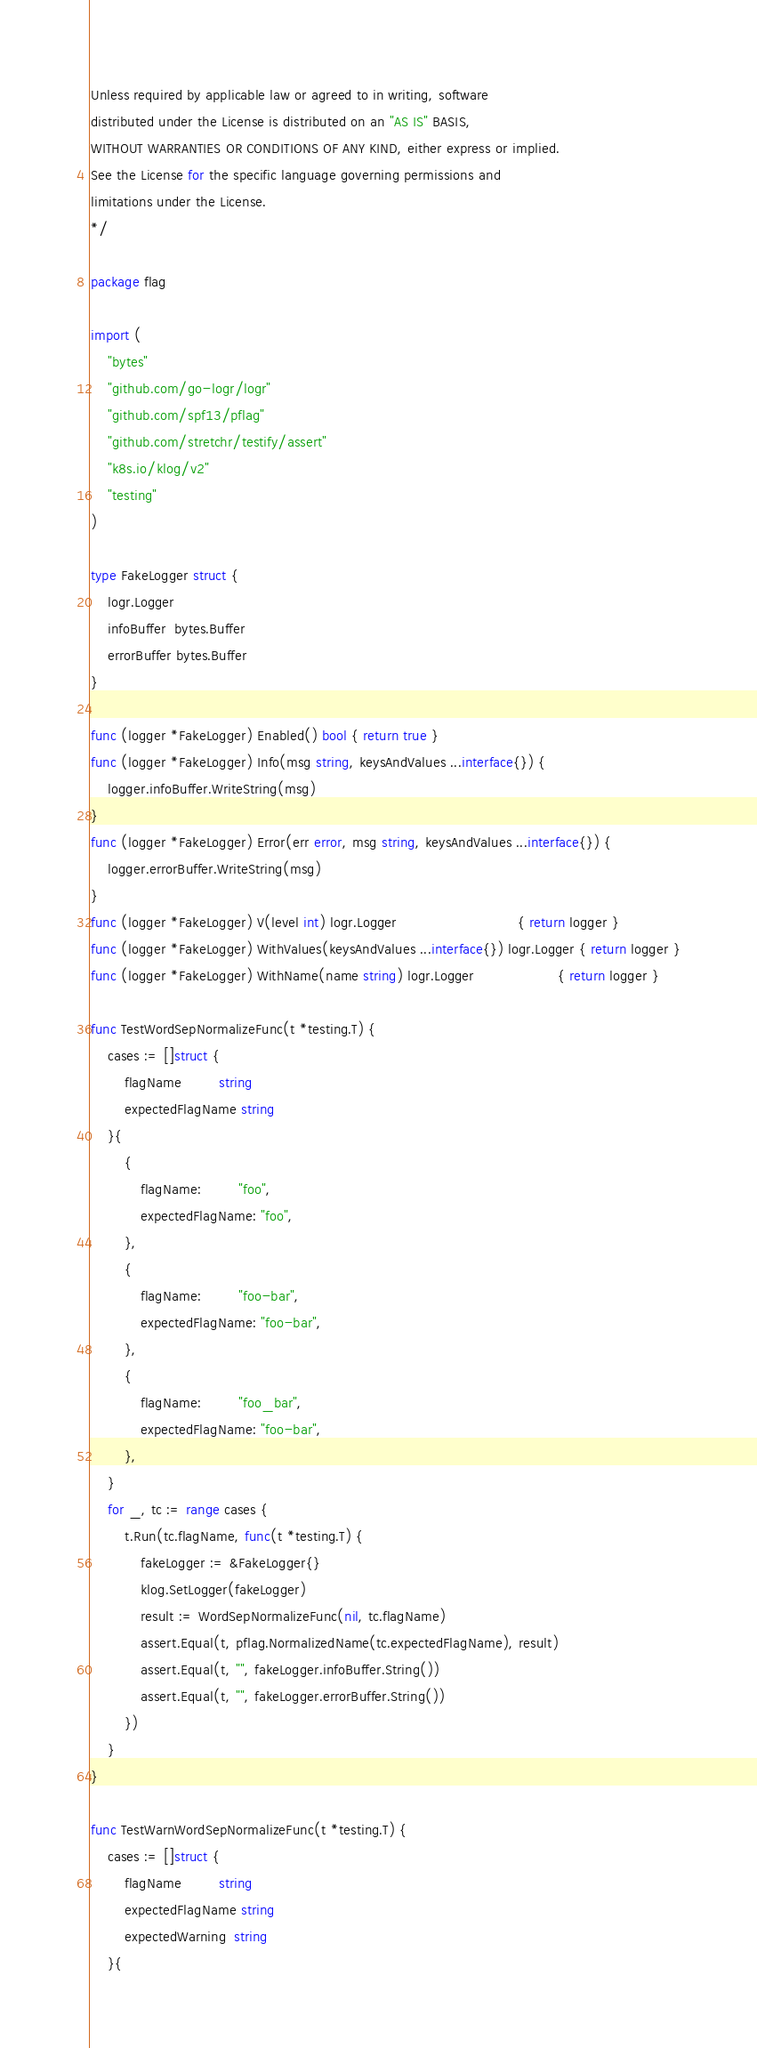<code> <loc_0><loc_0><loc_500><loc_500><_Go_>Unless required by applicable law or agreed to in writing, software
distributed under the License is distributed on an "AS IS" BASIS,
WITHOUT WARRANTIES OR CONDITIONS OF ANY KIND, either express or implied.
See the License for the specific language governing permissions and
limitations under the License.
*/

package flag

import (
	"bytes"
	"github.com/go-logr/logr"
	"github.com/spf13/pflag"
	"github.com/stretchr/testify/assert"
	"k8s.io/klog/v2"
	"testing"
)

type FakeLogger struct {
	logr.Logger
	infoBuffer  bytes.Buffer
	errorBuffer bytes.Buffer
}

func (logger *FakeLogger) Enabled() bool { return true }
func (logger *FakeLogger) Info(msg string, keysAndValues ...interface{}) {
	logger.infoBuffer.WriteString(msg)
}
func (logger *FakeLogger) Error(err error, msg string, keysAndValues ...interface{}) {
	logger.errorBuffer.WriteString(msg)
}
func (logger *FakeLogger) V(level int) logr.Logger                             { return logger }
func (logger *FakeLogger) WithValues(keysAndValues ...interface{}) logr.Logger { return logger }
func (logger *FakeLogger) WithName(name string) logr.Logger                    { return logger }

func TestWordSepNormalizeFunc(t *testing.T) {
	cases := []struct {
		flagName         string
		expectedFlagName string
	}{
		{
			flagName:         "foo",
			expectedFlagName: "foo",
		},
		{
			flagName:         "foo-bar",
			expectedFlagName: "foo-bar",
		},
		{
			flagName:         "foo_bar",
			expectedFlagName: "foo-bar",
		},
	}
	for _, tc := range cases {
		t.Run(tc.flagName, func(t *testing.T) {
			fakeLogger := &FakeLogger{}
			klog.SetLogger(fakeLogger)
			result := WordSepNormalizeFunc(nil, tc.flagName)
			assert.Equal(t, pflag.NormalizedName(tc.expectedFlagName), result)
			assert.Equal(t, "", fakeLogger.infoBuffer.String())
			assert.Equal(t, "", fakeLogger.errorBuffer.String())
		})
	}
}

func TestWarnWordSepNormalizeFunc(t *testing.T) {
	cases := []struct {
		flagName         string
		expectedFlagName string
		expectedWarning  string
	}{</code> 